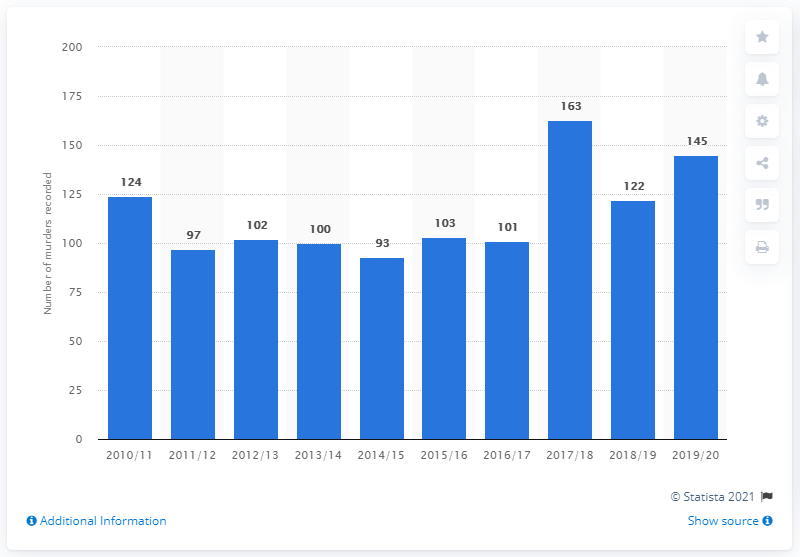Mention a couple of crucial points in this snapshot. There were 122 murders in 2019/2020. In 2014/15, the number of murders was 93, which was the lowest recorded number during that period. 